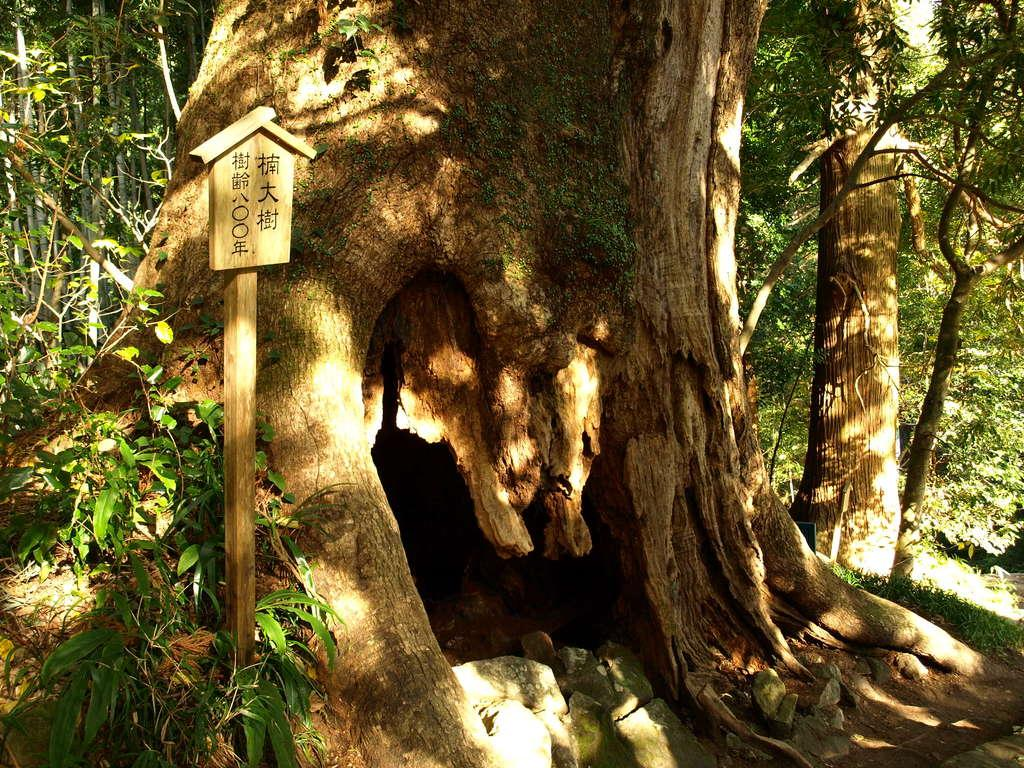What is on the board that is visible in the image? There is text on the board in the image. How is the board positioned in the image? The board is placed on a pole. What can be seen in the background of the image? There is a group of trees in the background of the image. How many balls are hanging from the kettle in the image? There is no kettle or balls present in the image. Is there a swing visible in the image? No, there is no swing visible in the image. 